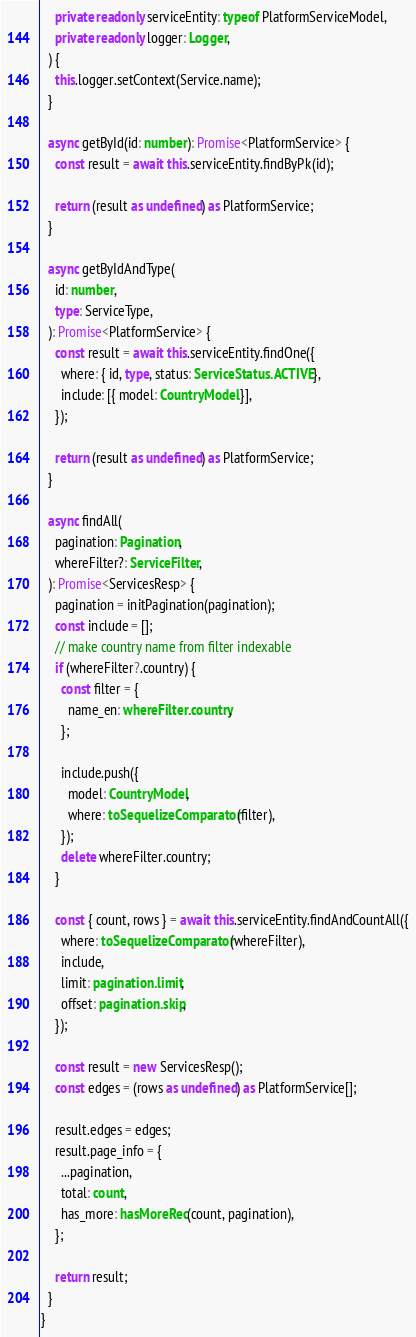<code> <loc_0><loc_0><loc_500><loc_500><_TypeScript_>    private readonly serviceEntity: typeof PlatformServiceModel,
    private readonly logger: Logger,
  ) {
    this.logger.setContext(Service.name);
  }

  async getById(id: number): Promise<PlatformService> {
    const result = await this.serviceEntity.findByPk(id);

    return (result as undefined) as PlatformService;
  }

  async getByIdAndType(
    id: number,
    type: ServiceType,
  ): Promise<PlatformService> {
    const result = await this.serviceEntity.findOne({
      where: { id, type, status: ServiceStatus.ACTIVE },
      include: [{ model: CountryModel }],
    });

    return (result as undefined) as PlatformService;
  }

  async findAll(
    pagination: Pagination,
    whereFilter?: ServiceFilter,
  ): Promise<ServicesResp> {
    pagination = initPagination(pagination);
    const include = [];
    // make country name from filter indexable
    if (whereFilter?.country) {
      const filter = {
        name_en: whereFilter.country,
      };

      include.push({
        model: CountryModel,
        where: toSequelizeComparator(filter),
      });
      delete whereFilter.country;
    }

    const { count, rows } = await this.serviceEntity.findAndCountAll({
      where: toSequelizeComparator(whereFilter),
      include,
      limit: pagination.limit,
      offset: pagination.skip,
    });

    const result = new ServicesResp();
    const edges = (rows as undefined) as PlatformService[];

    result.edges = edges;
    result.page_info = {
      ...pagination,
      total: count,
      has_more: hasMoreRec(count, pagination),
    };

    return result;
  }
}
</code> 